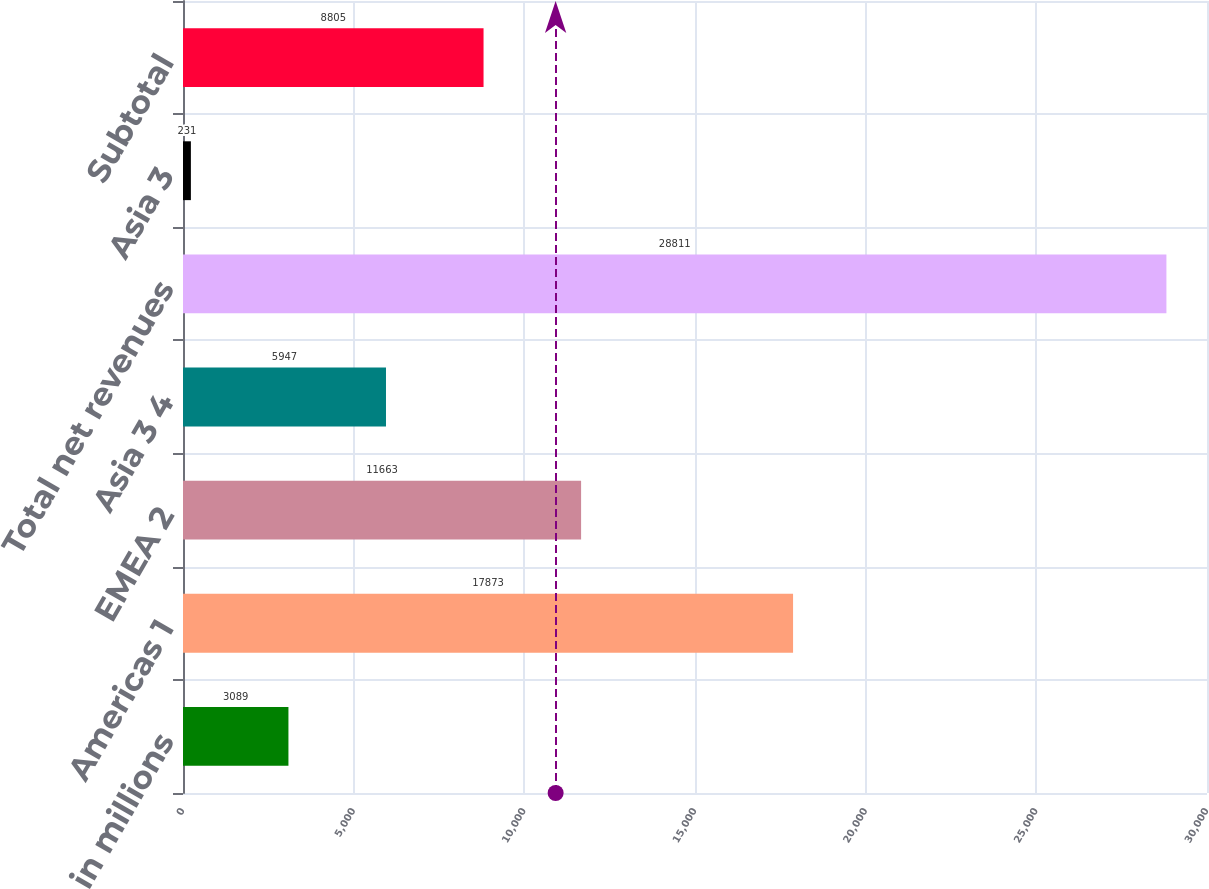<chart> <loc_0><loc_0><loc_500><loc_500><bar_chart><fcel>in millions<fcel>Americas 1<fcel>EMEA 2<fcel>Asia 3 4<fcel>Total net revenues<fcel>Asia 3<fcel>Subtotal<nl><fcel>3089<fcel>17873<fcel>11663<fcel>5947<fcel>28811<fcel>231<fcel>8805<nl></chart> 